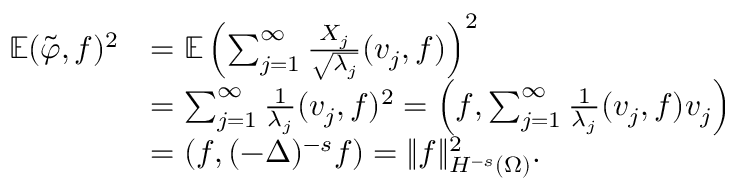<formula> <loc_0><loc_0><loc_500><loc_500>\begin{array} { r l } { \mathbb { E } ( \tilde { \varphi } , f ) ^ { 2 } } & { = \mathbb { E } \left ( \sum _ { j = 1 } ^ { \infty } \frac { X _ { j } } { \sqrt { \lambda _ { j } } } ( v _ { j } , f ) \right ) ^ { 2 } } \\ & { = \sum _ { j = 1 } ^ { \infty } \frac { 1 } { \lambda _ { j } } ( v _ { j } , f ) ^ { 2 } = \left ( f , \sum _ { j = 1 } ^ { \infty } \frac { 1 } { \lambda _ { j } } ( v _ { j } , f ) v _ { j } \right ) } \\ & { = \left ( f , ( - \Delta ) ^ { - s } f \right ) = \| f \| _ { H ^ { - s } ( \Omega ) } ^ { 2 } . } \end{array}</formula> 